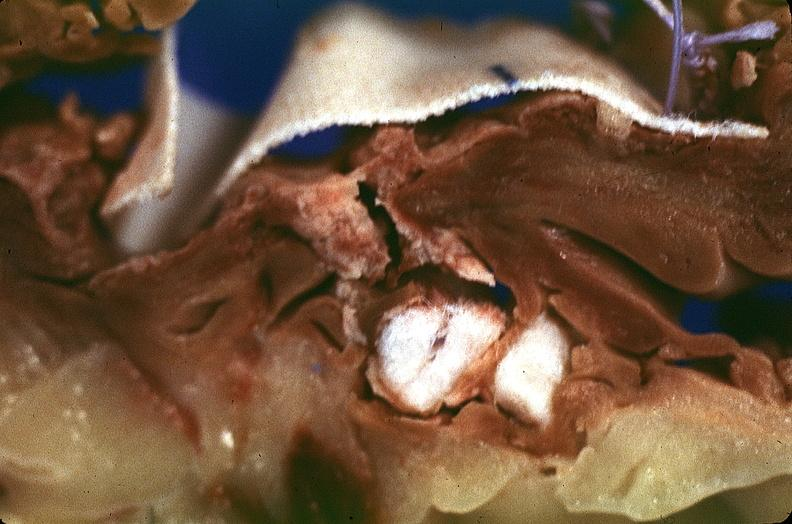what does this image show?
Answer the question using a single word or phrase. Heart 